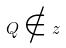<formula> <loc_0><loc_0><loc_500><loc_500>Q \notin z</formula> 